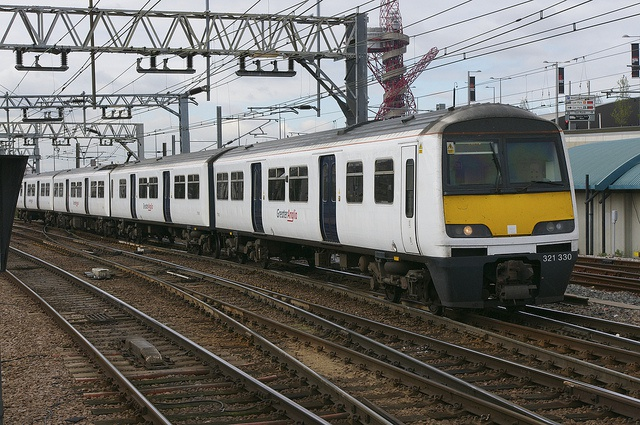Describe the objects in this image and their specific colors. I can see a train in lightgray, black, darkgray, and gray tones in this image. 